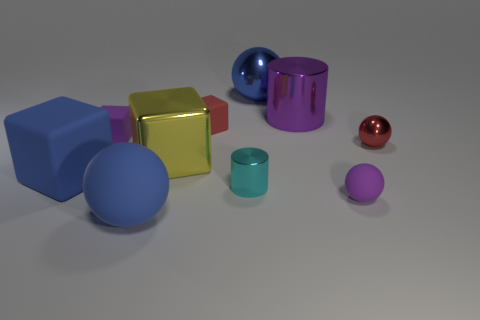What might be the purpose of arranging these objects in this way? The arrangement seems to be intentionally designed to display a diversity of shapes and colors, perhaps for an art piece, a graphic design project, or even a 3D modeling demonstration. The purpose could be aesthetic or educational, showcasing the rendering capabilities of a software or creating a visually pleasing composition. 